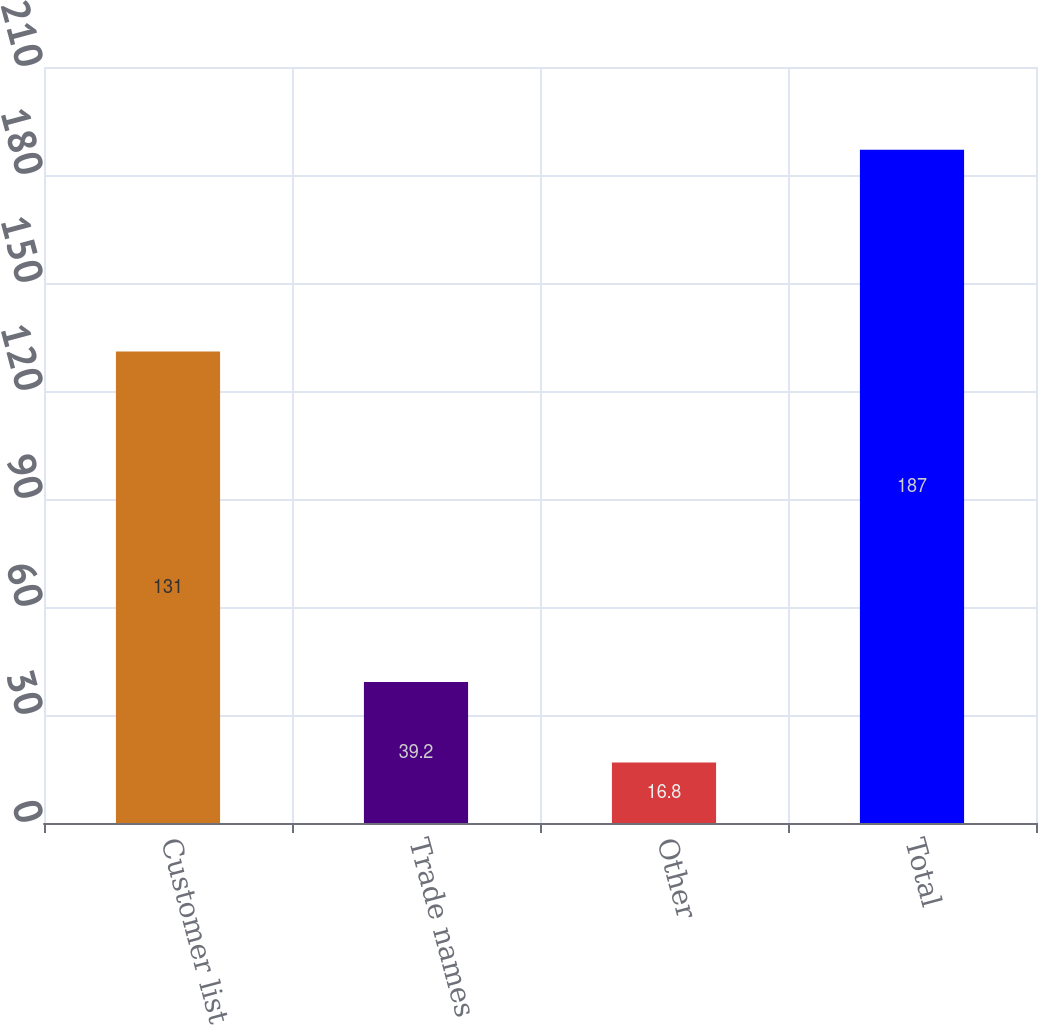<chart> <loc_0><loc_0><loc_500><loc_500><bar_chart><fcel>Customer list<fcel>Trade names<fcel>Other<fcel>Total<nl><fcel>131<fcel>39.2<fcel>16.8<fcel>187<nl></chart> 